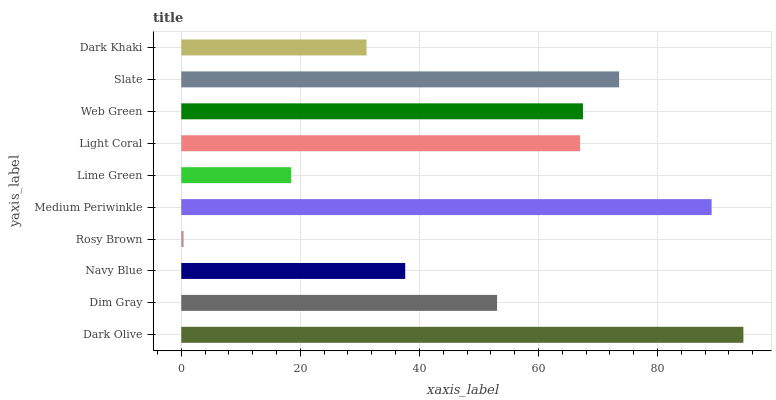Is Rosy Brown the minimum?
Answer yes or no. Yes. Is Dark Olive the maximum?
Answer yes or no. Yes. Is Dim Gray the minimum?
Answer yes or no. No. Is Dim Gray the maximum?
Answer yes or no. No. Is Dark Olive greater than Dim Gray?
Answer yes or no. Yes. Is Dim Gray less than Dark Olive?
Answer yes or no. Yes. Is Dim Gray greater than Dark Olive?
Answer yes or no. No. Is Dark Olive less than Dim Gray?
Answer yes or no. No. Is Light Coral the high median?
Answer yes or no. Yes. Is Dim Gray the low median?
Answer yes or no. Yes. Is Dark Olive the high median?
Answer yes or no. No. Is Dark Olive the low median?
Answer yes or no. No. 